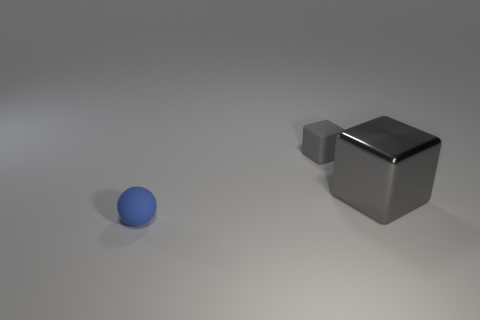There is another tiny thing that is the same color as the metallic object; what is it made of?
Your answer should be very brief. Rubber. Are there any other big things that have the same shape as the blue matte thing?
Your response must be concise. No. Does the gray block that is behind the gray metallic block have the same size as the tiny blue rubber ball?
Your answer should be compact. Yes. There is a object that is both to the right of the blue rubber object and on the left side of the big block; how big is it?
Make the answer very short. Small. How many other objects are there of the same material as the large gray cube?
Your response must be concise. 0. There is a matte thing behind the tiny blue object; what is its size?
Offer a very short reply. Small. Is the color of the ball the same as the matte cube?
Give a very brief answer. No. How many large objects are blue objects or gray blocks?
Your answer should be compact. 1. Is there anything else that has the same color as the rubber ball?
Your response must be concise. No. Are there any small blue spheres behind the tiny blue thing?
Provide a succinct answer. No. 